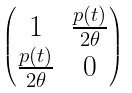<formula> <loc_0><loc_0><loc_500><loc_500>\begin{pmatrix} 1 & \frac { p ( t ) } { 2 \theta } \\ \frac { p ( t ) } { 2 \theta } & 0 \end{pmatrix}</formula> 